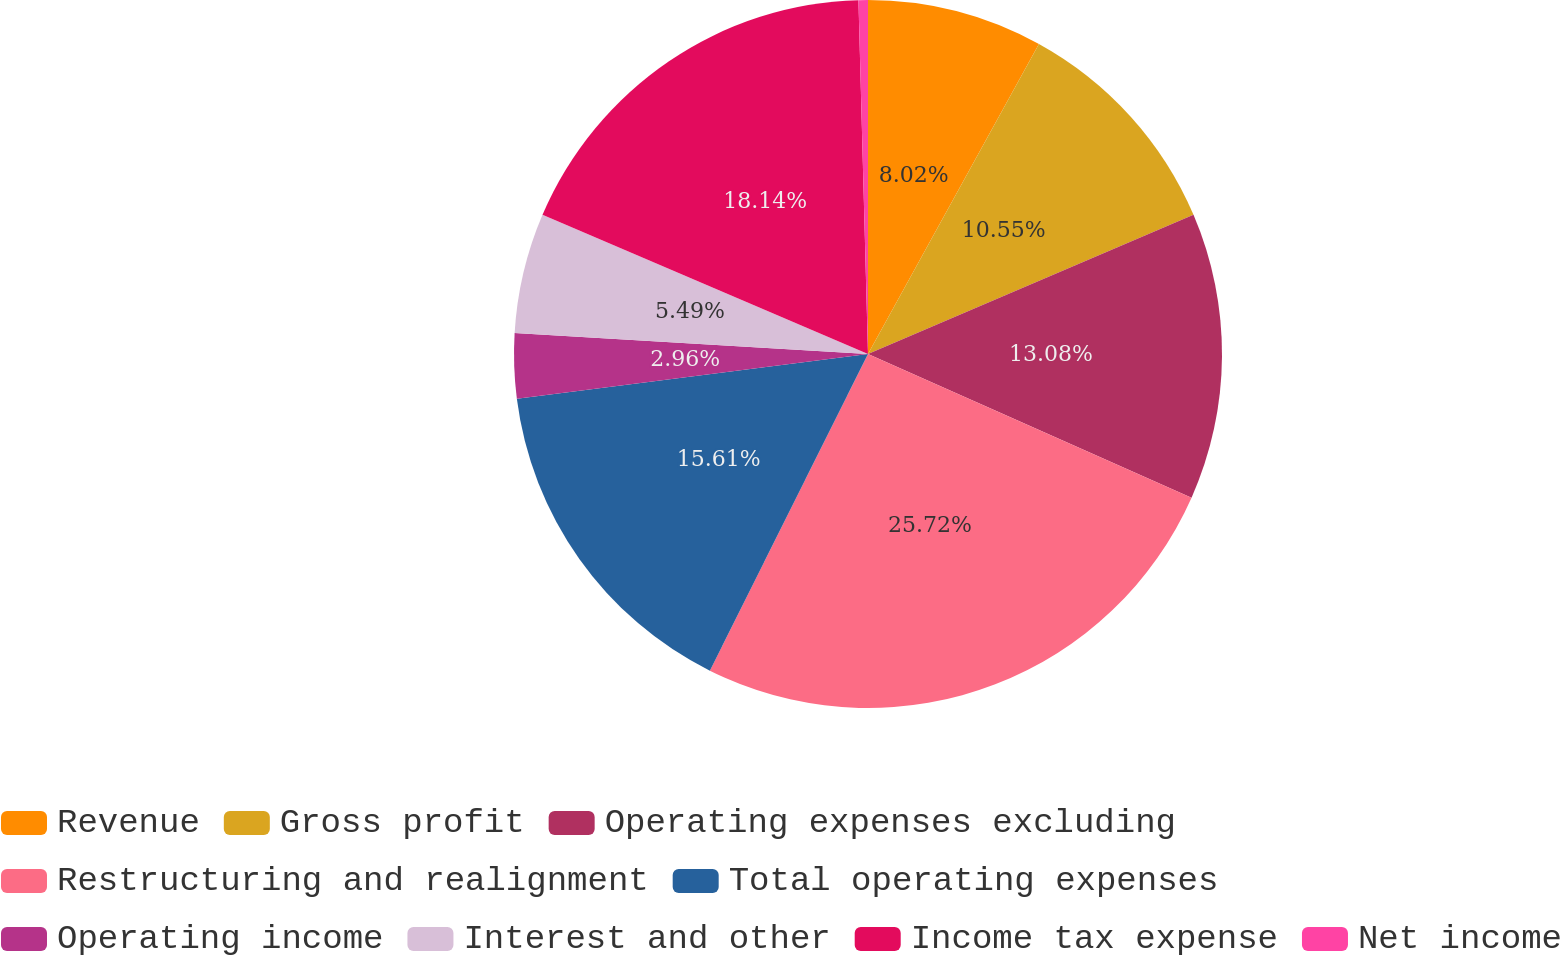<chart> <loc_0><loc_0><loc_500><loc_500><pie_chart><fcel>Revenue<fcel>Gross profit<fcel>Operating expenses excluding<fcel>Restructuring and realignment<fcel>Total operating expenses<fcel>Operating income<fcel>Interest and other<fcel>Income tax expense<fcel>Net income<nl><fcel>8.02%<fcel>10.55%<fcel>13.08%<fcel>25.72%<fcel>15.61%<fcel>2.96%<fcel>5.49%<fcel>18.14%<fcel>0.43%<nl></chart> 